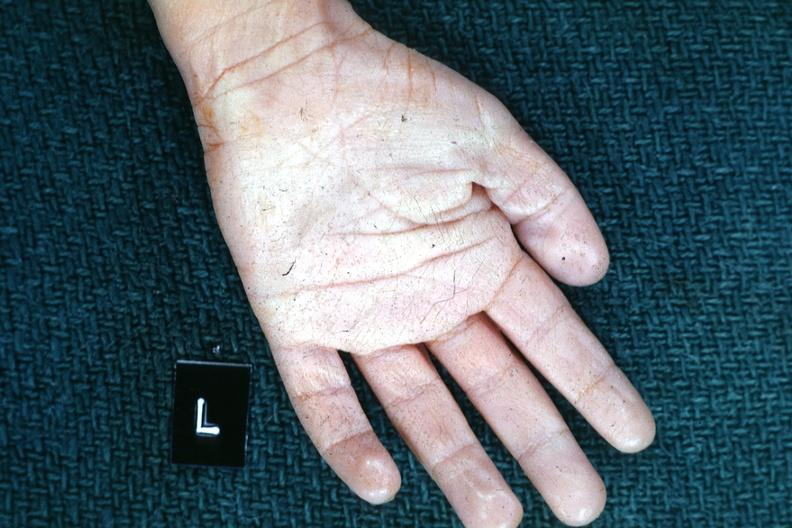what are present?
Answer the question using a single word or phrase. Extremities 